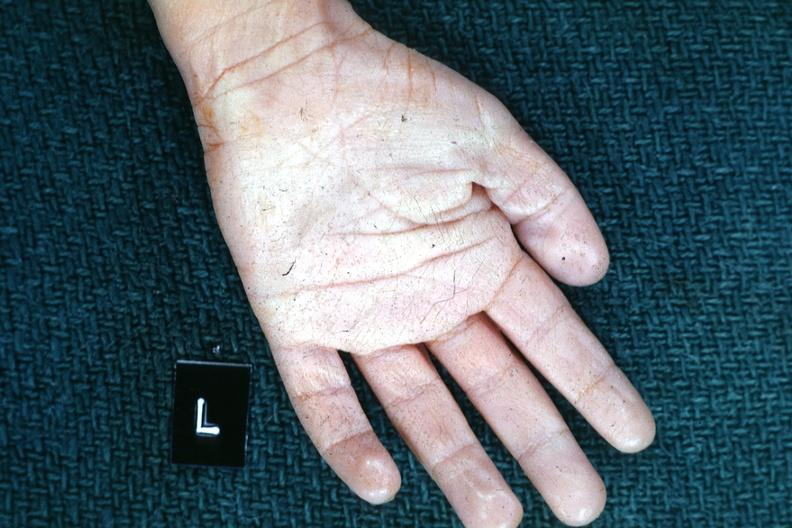what are present?
Answer the question using a single word or phrase. Extremities 